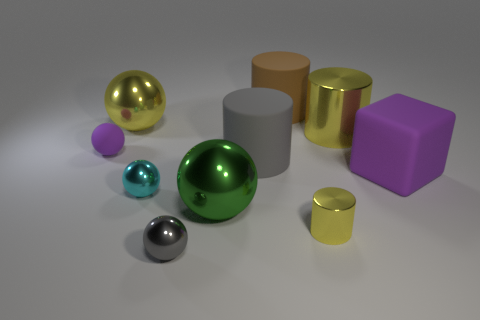Subtract 1 cylinders. How many cylinders are left? 3 Subtract all cyan spheres. How many spheres are left? 4 Subtract all small gray spheres. How many spheres are left? 4 Subtract all blue balls. Subtract all red cylinders. How many balls are left? 5 Subtract all cylinders. How many objects are left? 6 Add 7 yellow metallic cylinders. How many yellow metallic cylinders are left? 9 Add 4 purple matte balls. How many purple matte balls exist? 5 Subtract 0 brown blocks. How many objects are left? 10 Subtract all tiny gray metallic balls. Subtract all large gray cylinders. How many objects are left? 8 